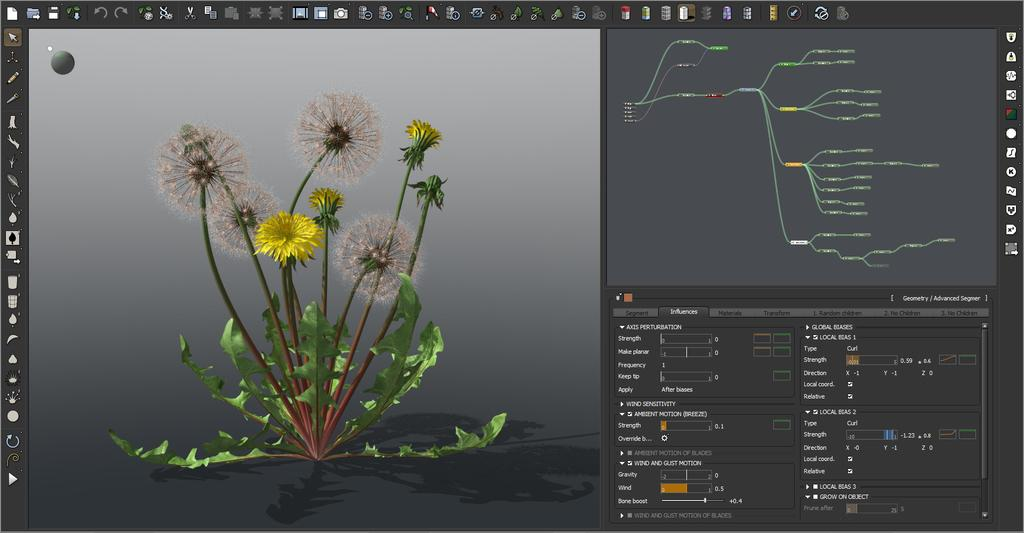What can be seen on the left side of the picture? There is a 3D image on the left side of the picture. What is visible on the right side of the picture? There are many editing tools visible on a computer display on the right side of the picture. How many boats are visible in the 3D on the left side of the picture? There are no boats visible in the 3D image on the left side of the picture. What type of chin is shown in the picture? There is no chin present in the picture; it features a 3D image and editing tools on a computer display. 